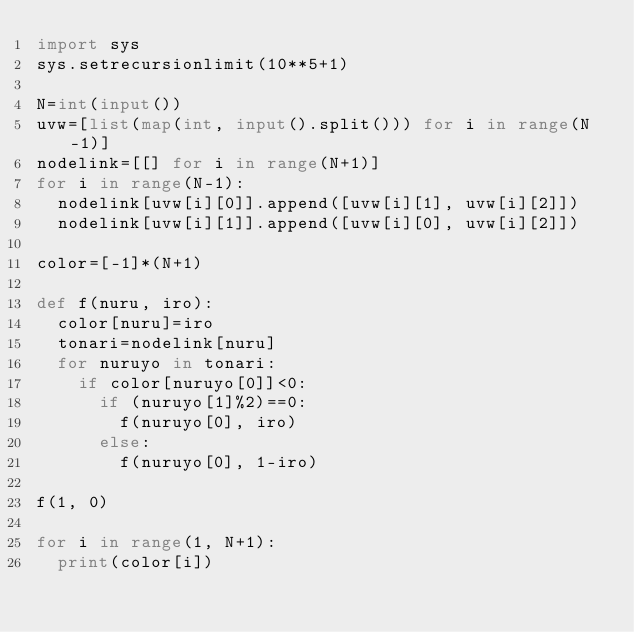<code> <loc_0><loc_0><loc_500><loc_500><_Python_>import sys
sys.setrecursionlimit(10**5+1)

N=int(input())
uvw=[list(map(int, input().split())) for i in range(N-1)]
nodelink=[[] for i in range(N+1)]
for i in range(N-1):
  nodelink[uvw[i][0]].append([uvw[i][1], uvw[i][2]])
  nodelink[uvw[i][1]].append([uvw[i][0], uvw[i][2]])
  
color=[-1]*(N+1)

def f(nuru, iro):
  color[nuru]=iro
  tonari=nodelink[nuru]
  for nuruyo in tonari:
    if color[nuruyo[0]]<0:
      if (nuruyo[1]%2)==0:
        f(nuruyo[0], iro)
      else:
        f(nuruyo[0], 1-iro)
      
f(1, 0)

for i in range(1, N+1):
  print(color[i])</code> 